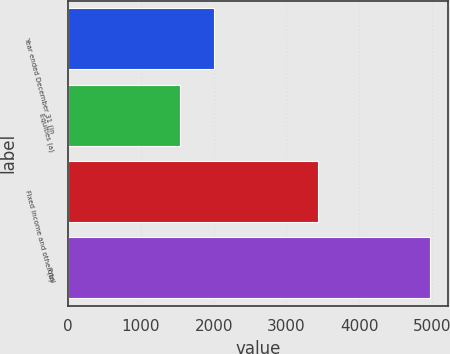Convert chart to OTSL. <chart><loc_0><loc_0><loc_500><loc_500><bar_chart><fcel>Year ended December 31 (in<fcel>Equities (a)<fcel>Fixed income and other (b)<fcel>Total<nl><fcel>2001<fcel>1541<fcel>3431<fcel>4972<nl></chart> 